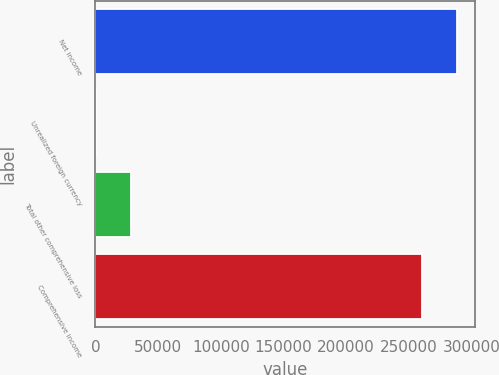Convert chart to OTSL. <chart><loc_0><loc_0><loc_500><loc_500><bar_chart><fcel>Net income<fcel>Unrealized foreign currency<fcel>Total other comprehensive loss<fcel>Comprehensive income<nl><fcel>288532<fcel>183<fcel>28440.5<fcel>260274<nl></chart> 